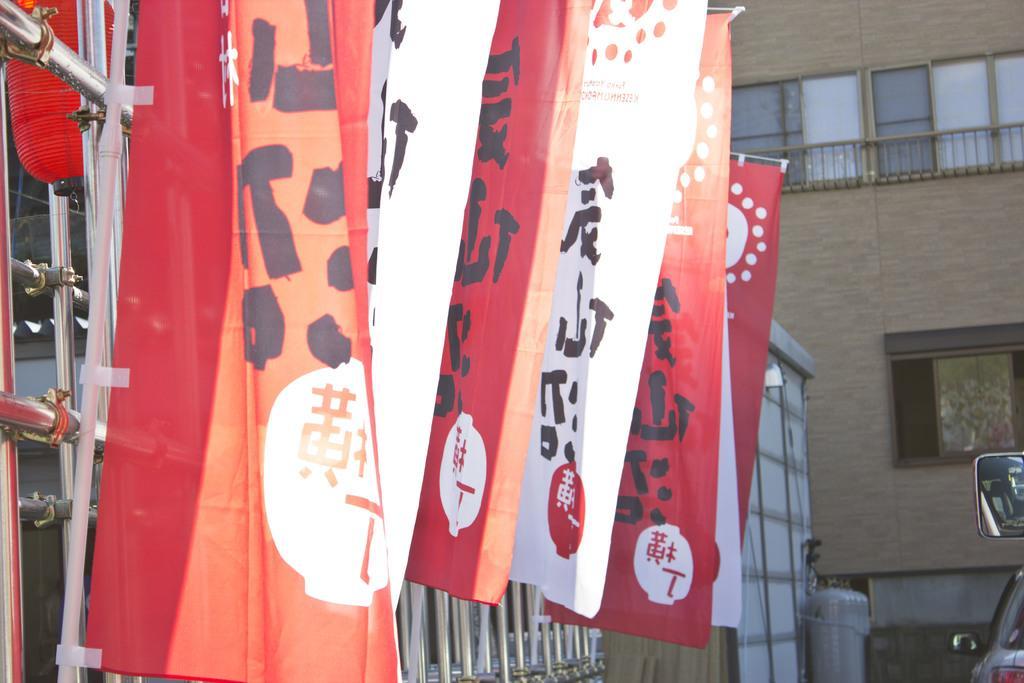In one or two sentences, can you explain what this image depicts? In this image I can see boards, flags, metal rods, vehicles on the road and buildings. This image is taken during a day. 